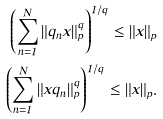<formula> <loc_0><loc_0><loc_500><loc_500>\left ( \sum _ { n = 1 } ^ { N } \| q _ { n } x \| _ { p } ^ { q } \right ) ^ { 1 / q } \leq \| x \| _ { p } \\ \left ( \sum _ { n = 1 } ^ { N } \| x q _ { n } \| _ { p } ^ { q } \right ) ^ { 1 / q } \leq \| x \| _ { p } .</formula> 